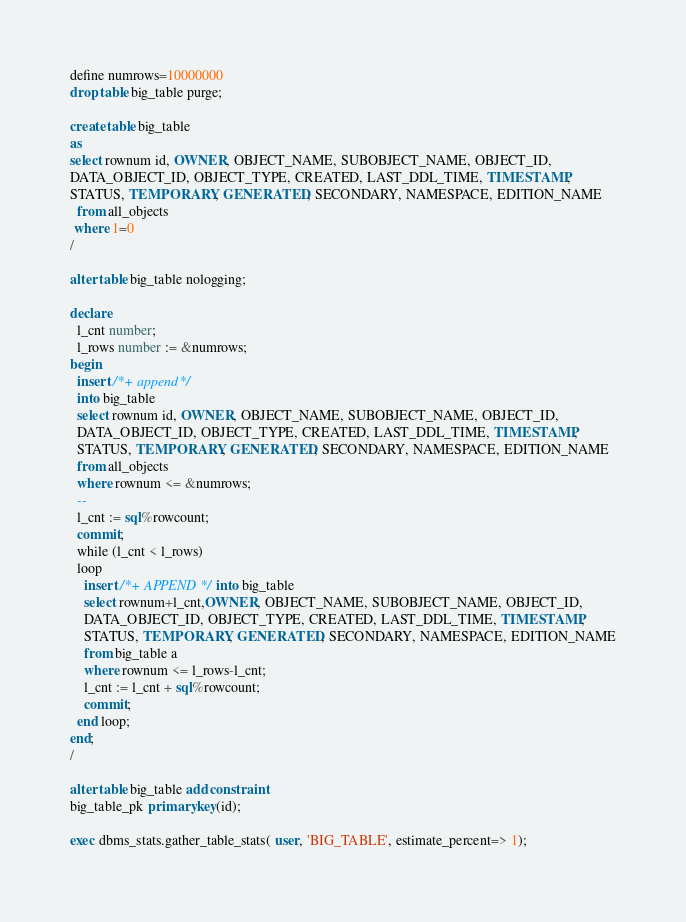<code> <loc_0><loc_0><loc_500><loc_500><_SQL_>define numrows=10000000
drop table big_table purge;

create table big_table
as
select rownum id, OWNER, OBJECT_NAME, SUBOBJECT_NAME, OBJECT_ID,
DATA_OBJECT_ID, OBJECT_TYPE, CREATED, LAST_DDL_TIME, TIMESTAMP,
STATUS, TEMPORARY, GENERATED, SECONDARY, NAMESPACE, EDITION_NAME
  from all_objects
 where 1=0
/

alter table big_table nologging;

declare
  l_cnt number;
  l_rows number := &numrows;
begin
  insert /*+ append */
  into big_table
  select rownum id, OWNER, OBJECT_NAME, SUBOBJECT_NAME, OBJECT_ID,
  DATA_OBJECT_ID, OBJECT_TYPE, CREATED, LAST_DDL_TIME, TIMESTAMP,
  STATUS, TEMPORARY, GENERATED, SECONDARY, NAMESPACE, EDITION_NAME
  from all_objects
  where rownum <= &numrows;
  --
  l_cnt := sql%rowcount;
  commit;
  while (l_cnt < l_rows)
  loop
    insert /*+ APPEND */ into big_table
    select rownum+l_cnt,OWNER, OBJECT_NAME, SUBOBJECT_NAME, OBJECT_ID,
    DATA_OBJECT_ID, OBJECT_TYPE, CREATED, LAST_DDL_TIME, TIMESTAMP,
    STATUS, TEMPORARY, GENERATED, SECONDARY, NAMESPACE, EDITION_NAME
    from big_table a
    where rownum <= l_rows-l_cnt;
    l_cnt := l_cnt + sql%rowcount;
    commit;
  end loop;
end;
/

alter table big_table add constraint
big_table_pk primary key(id);

exec dbms_stats.gather_table_stats( user, 'BIG_TABLE', estimate_percent=> 1);
</code> 